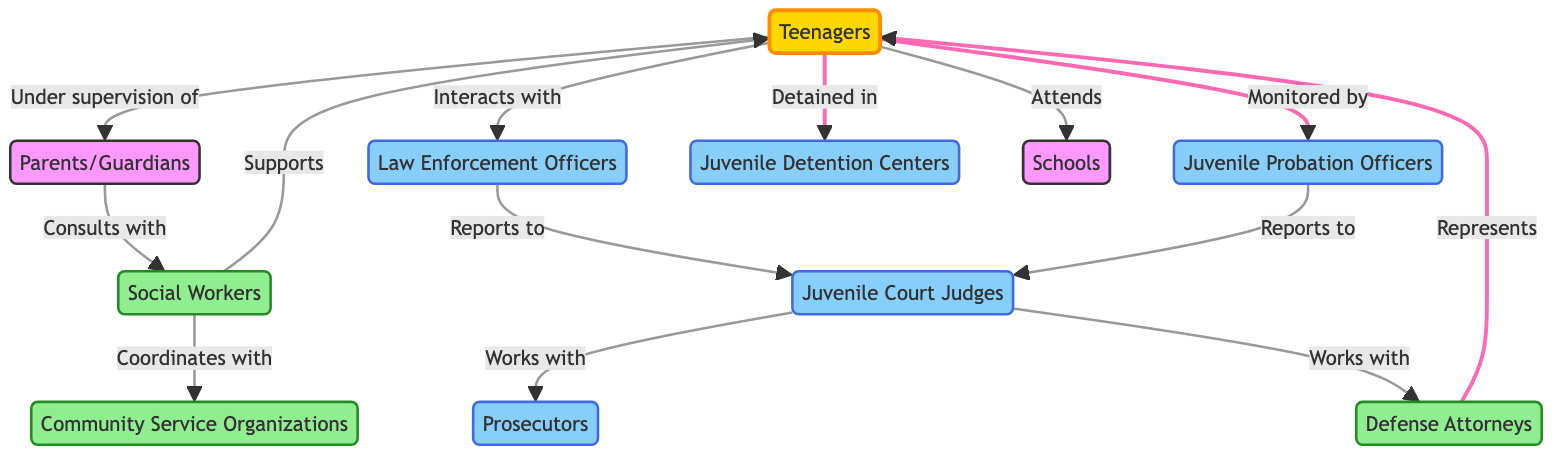What are the key stakeholders in the juvenile justice system? The nodes in the diagram include Teenagers, Parents/Guardians, Law Enforcement Officers, Juvenile Court Judges, Juvenile Probation Officers, Prosecutors, Defense Attorneys, Social Workers, Juvenile Detention Centers, Community Service Organizations, and Schools.
Answer: Teenagers, Parents/Guardians, Law Enforcement Officers, Juvenile Court Judges, Juvenile Probation Officers, Prosecutors, Defense Attorneys, Social Workers, Juvenile Detention Centers, Community Service Organizations, Schools How many edges are present in the diagram? By counting the connections (edges) listed between the nodes, there are a total of 13 connections depicted in the diagram.
Answer: 13 Who do teenagers interact with in the juvenile justice system? The diagram shows that Teenagers interact with Law Enforcement Officers, and they are also monitored by Juvenile Probation Officers.
Answer: Law Enforcement Officers, Juvenile Probation Officers What does the juvenile court judge work with? The diagram indicates that Juvenile Court Judges work with Prosecutors and Defense Attorneys, as shown by the edges connected to these nodes.
Answer: Prosecutors, Defense Attorneys How is the juvenile probation officer connected in the system? The diagram indicates that Juvenile Probation Officers report to Juvenile Court Judges and also monitor Teenagers. This dual connection illustrates their role in both reporting and oversight.
Answer: Reports to Juvenile Court Judges, Monitored by Teenagers Which stakeholder supports teenagers in the system? According to the diagram, Social Workers provide support to Teenagers, shown through the edge connecting these two nodes with a support label.
Answer: Social Workers What is the relationship between parents/guardians and social workers? The diagram indicates that Parents/Guardians consult with Social Workers, which highlights their role in seeking guidance or assistance regarding Teenagers.
Answer: Consults with How does the juvenile court judge interact with law enforcement officers? The diagram shows the juvenile court judge receives reports from Law Enforcement Officers, establishing a relationship of communication and information flow between these stakeholders.
Answer: Reports to What role do defense attorneys play in the juvenile justice system? The diagram highlights that Defense Attorneys represent Teenagers and work with Juvenile Court Judges. This means they advocate for the rights and cases of the Teenagers in court.
Answer: Represents Teenagers, Works with Juvenile Court Judges 